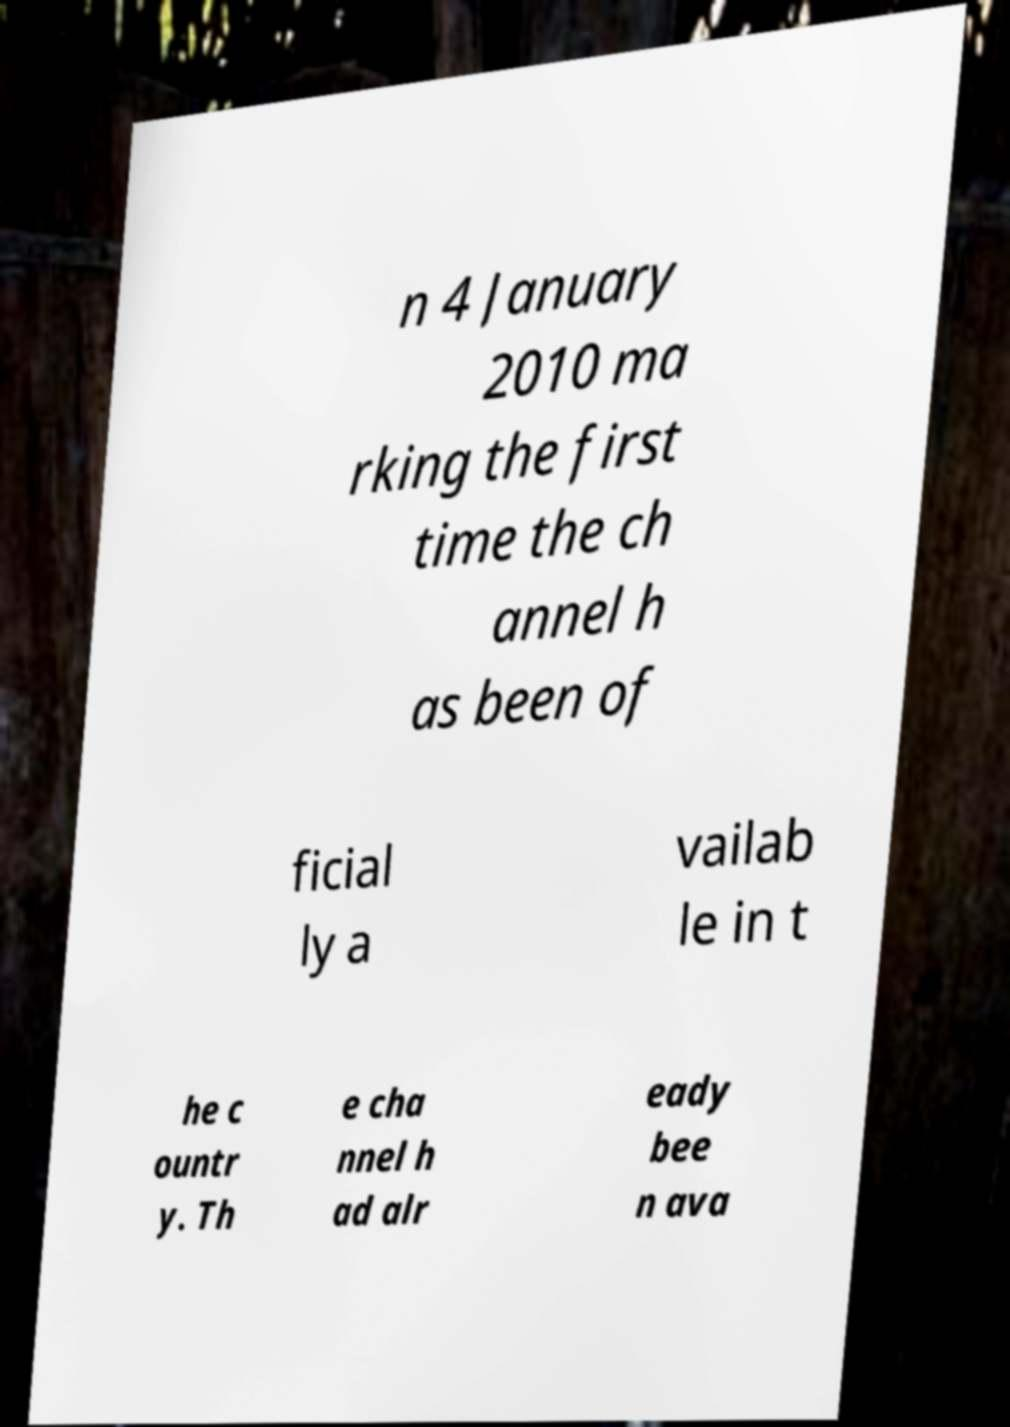Could you assist in decoding the text presented in this image and type it out clearly? n 4 January 2010 ma rking the first time the ch annel h as been of ficial ly a vailab le in t he c ountr y. Th e cha nnel h ad alr eady bee n ava 